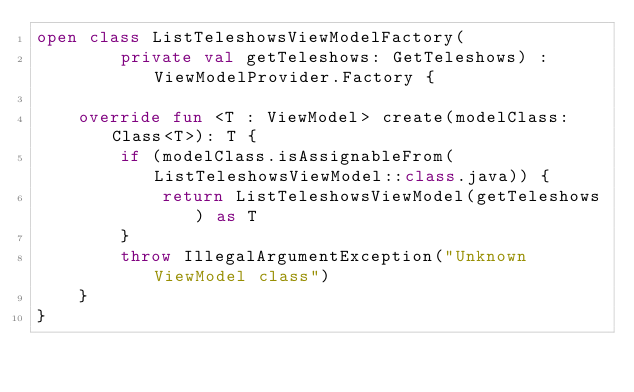<code> <loc_0><loc_0><loc_500><loc_500><_Kotlin_>open class ListTeleshowsViewModelFactory(
        private val getTeleshows: GetTeleshows) : ViewModelProvider.Factory {

    override fun <T : ViewModel> create(modelClass: Class<T>): T {
        if (modelClass.isAssignableFrom(ListTeleshowsViewModel::class.java)) {
            return ListTeleshowsViewModel(getTeleshows) as T
        }
        throw IllegalArgumentException("Unknown ViewModel class")
    }
}
</code> 